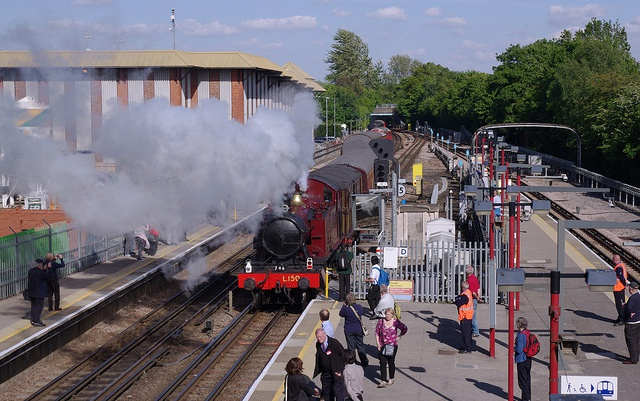Describe the objects in this image and their specific colors. I can see people in darkgray, black, gray, and maroon tones, train in darkgray, black, gray, maroon, and brown tones, people in darkgray, black, gray, and purple tones, people in darkgray, black, gray, and lightpink tones, and people in darkgray, black, gray, brown, and navy tones in this image. 